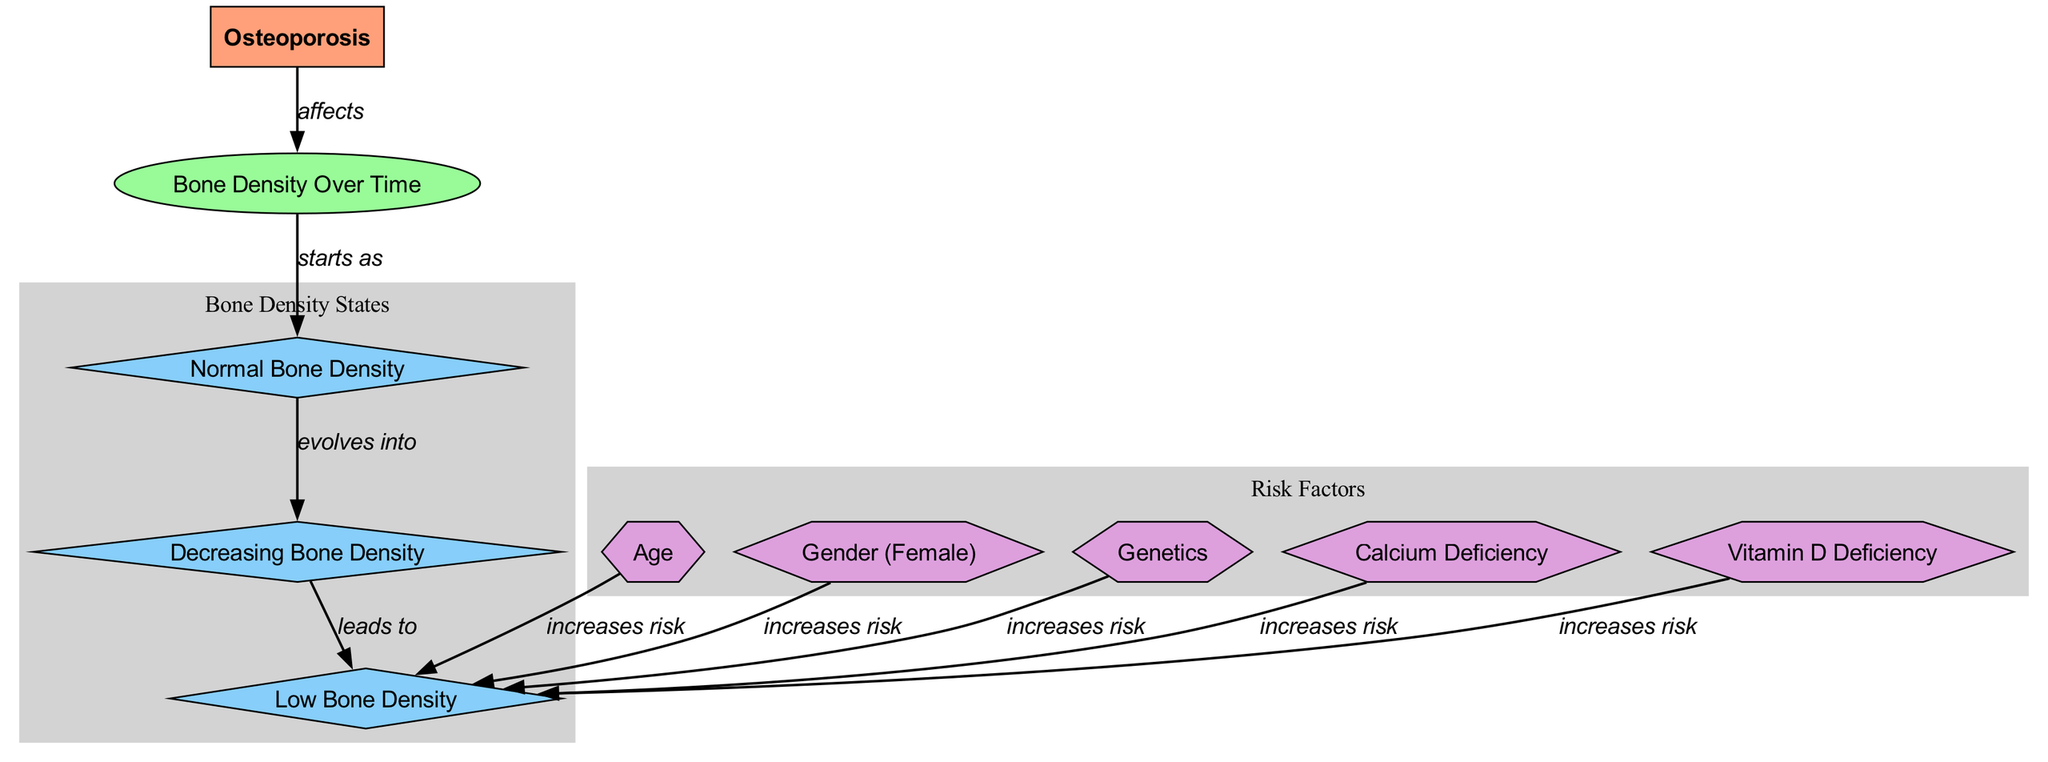What is the initial state of bone density in osteoporosis? The diagram indicates that osteoporosis starts as "Normal Bone Density," which is the first state node connected to "Bone Density Over Time."
Answer: Normal Bone Density How many risk factors are listed in the diagram? By counting the distinct nodes labeled as risk factors, we find five: Age, Gender (Female), Genetics, Calcium Deficiency, and Vitamin D Deficiency.
Answer: 5 What does "Decreasing Bone Density" evolve into? The diagram shows an edge from "Decreasing Bone Density" leading to "Low Bone Density," implying this is the next state in the progression.
Answer: Low Bone Density Which risk factor specifically pertains to gender? The diagram includes "Gender (Female)" as one of the risk factors that increases the risk of low bone density.
Answer: Gender (Female) What is the final state of bone density as it progresses in osteoporosis? The last state node reached in the diagram after following the progression from normal to low bone density is "Low Bone Density."
Answer: Low Bone Density Which risk factor is associated with dietary deficiency? The diagram highlights both "Calcium Deficiency" and "Vitamin D Deficiency," indicating they are associated with dietary lack impacting bone density.
Answer: Calcium Deficiency and Vitamin D Deficiency What relationship does "Age" have with "Low Bone Density"? The diagram specifies an edge indicating that "Age" increases the risk of reaching the state of "Low Bone Density."
Answer: increases risk What is the second state that occurs after normal bone density? According to the flow shown in the diagram, the second state following "Normal Bone Density" is "Decreasing Bone Density."
Answer: Decreasing Bone Density 